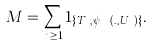Convert formula to latex. <formula><loc_0><loc_0><loc_500><loc_500>M = \sum _ { n \geq 1 } 1 _ { \{ T _ { n } , \psi _ { T _ { n } } ( . , U _ { n } ) \} } .</formula> 